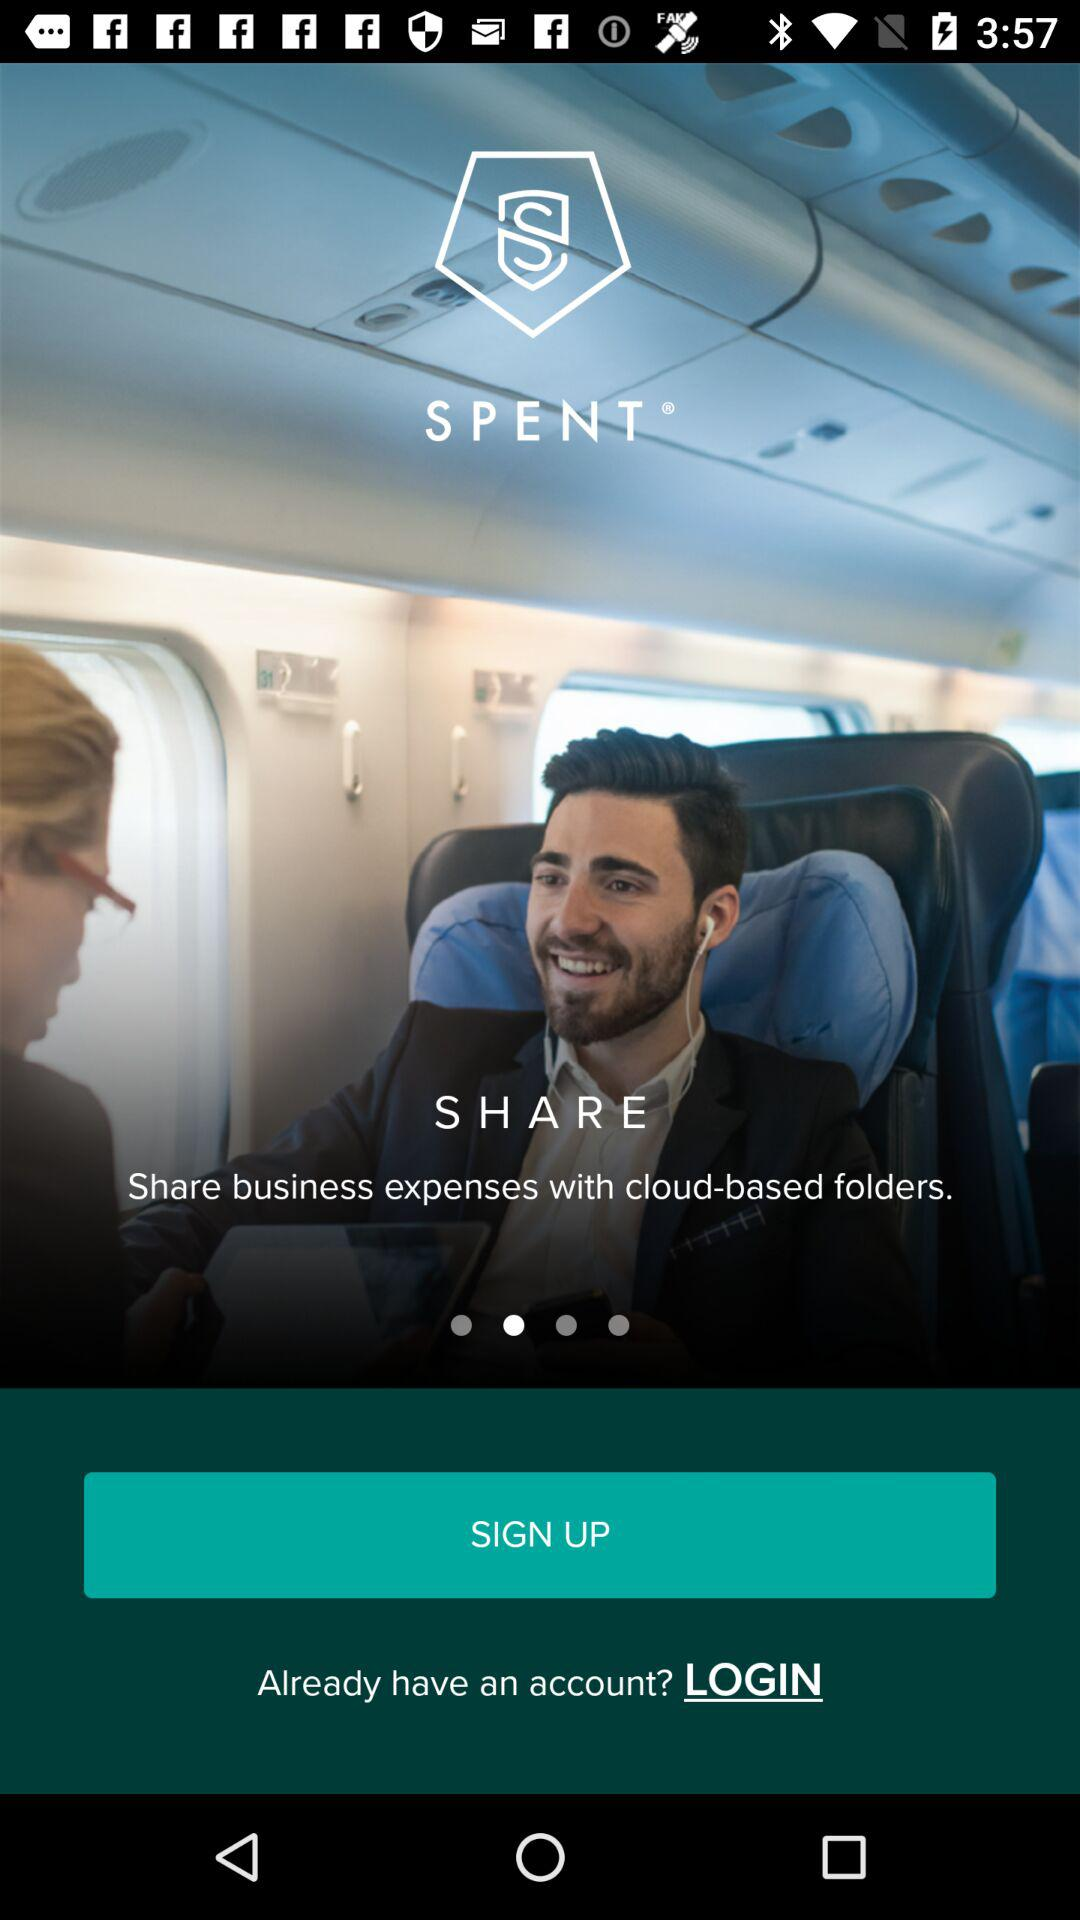What is the application name? The application name is "SPENT". 